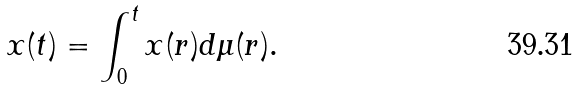<formula> <loc_0><loc_0><loc_500><loc_500>x ( t ) = \int _ { 0 } ^ { t } x ( r ) d \mu ( r ) .</formula> 